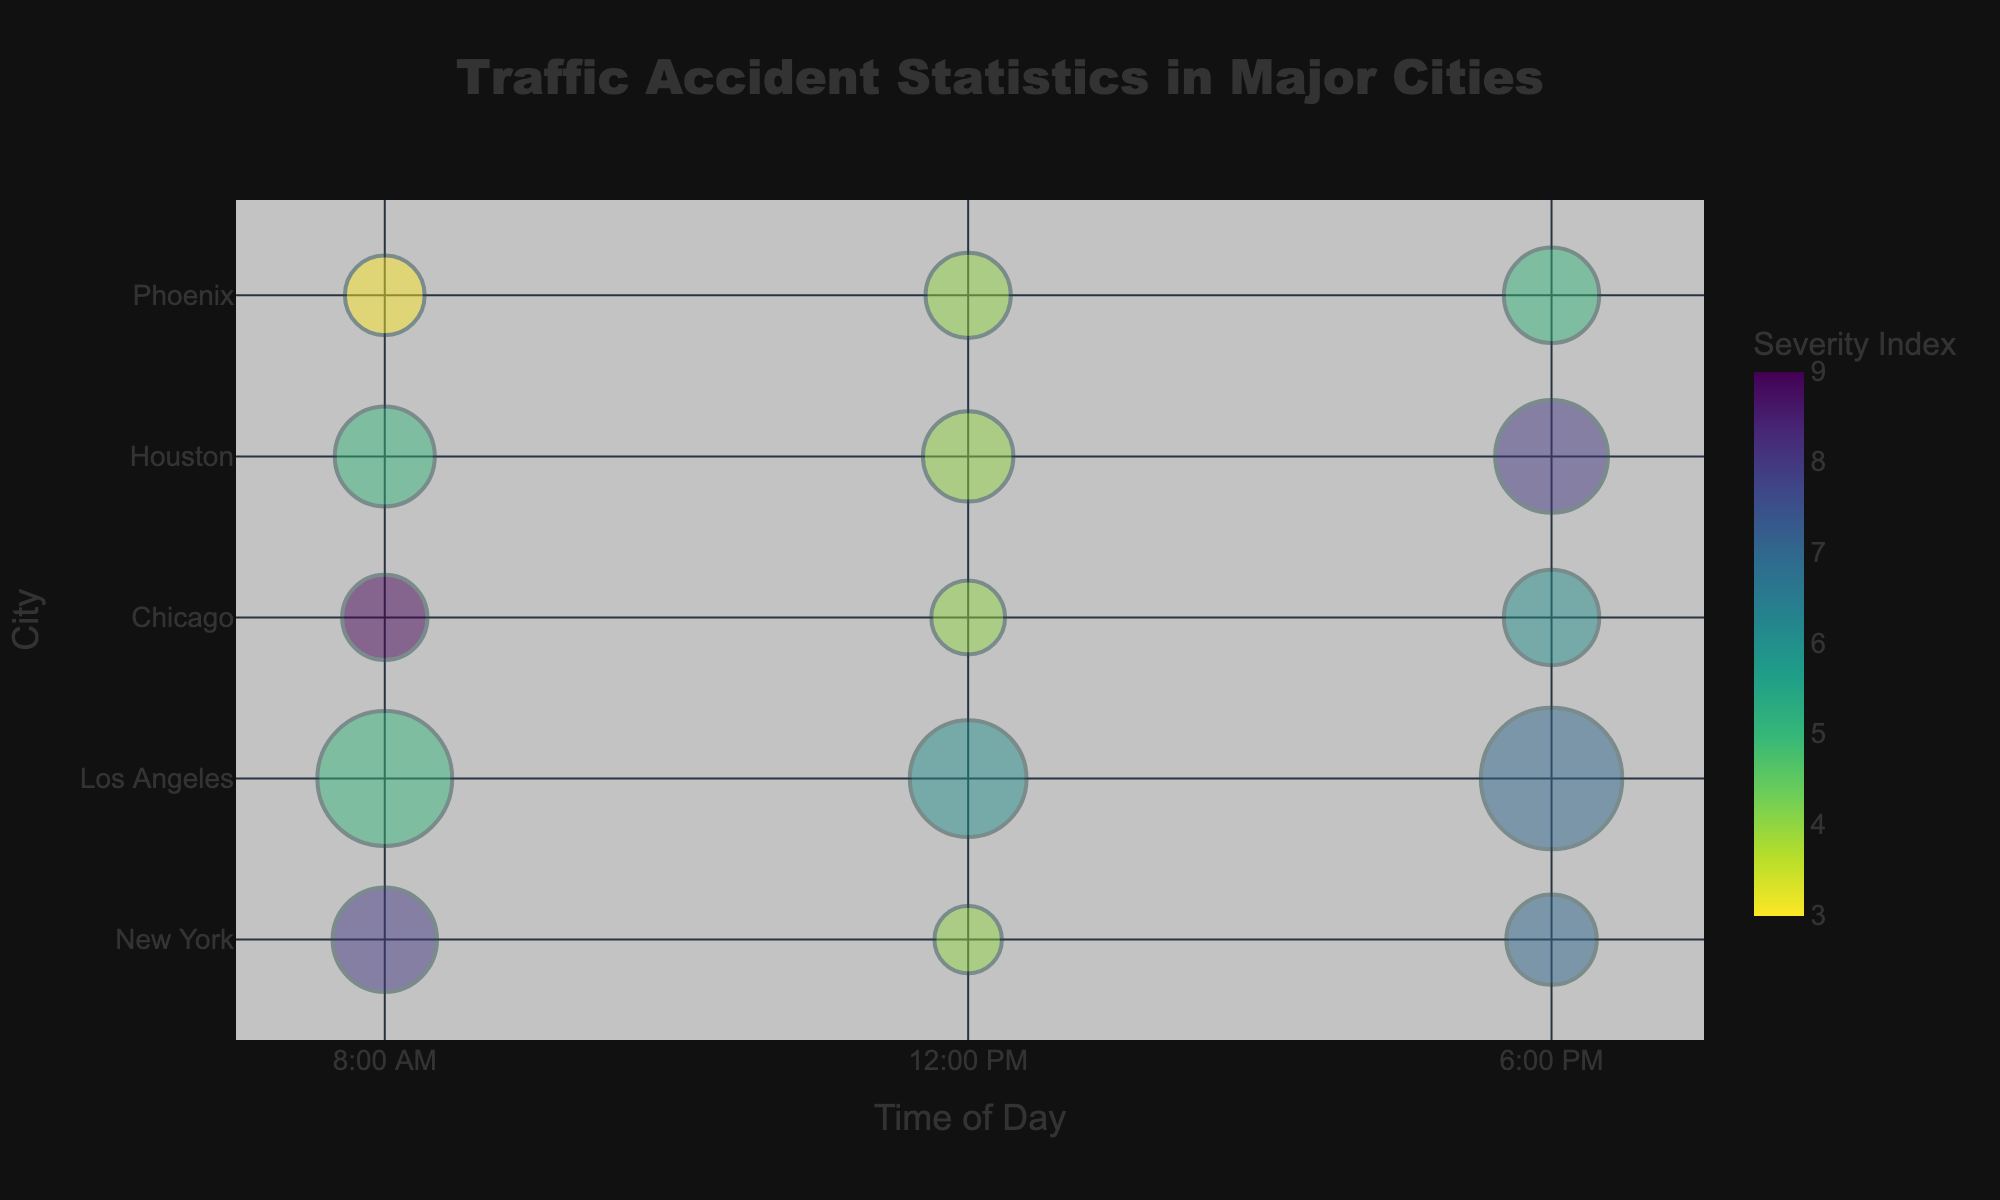What is the title of the bubble chart? The title is prominently displayed at the top center of the figure.
Answer: Traffic Accident Statistics in Major Cities How many major cities are represented in the bubble chart? The y-axis labels each major city included in the chart. By counting these labels, you can determine the number of cities.
Answer: 5 Which city had the highest number of traffic accidents at 6:00 PM? Identify the largest bubble at the 6:00 PM mark on the x-axis and check its y-axis positioning to find the corresponding city.
Answer: Los Angeles What time of day had the highest severity index in New York? Look for the bubble with the darkest color within the New York row to determine the corresponding time of day.
Answer: 8:00 AM Which weather condition is associated with traffic accidents in Houston at 6:00 PM? Hover over or check the data linked to the bubble at the 6:00 PM mark for Houston to find the weather condition listed.
Answer: Thunderstorm What is the combined number of traffic accidents for Los Angeles at 8:00 AM and 6:00 PM? Identify the bubble sizes for Los Angeles at 8:00 AM and 6:00 PM, and sum them up: 20 (8:00 AM) + 22 (6:00 PM).
Answer: 42 How many bubbles have the same size as the one representing Phoenix at 8:00 AM? Note the size of the bubble for Phoenix at 8:00 AM and count similar-sized bubbles across the chart.
Answer: 0 What time of day has the lowest severity index in Chicago? Look for the lightest-colored bubble within the Chicago row, indicating the lowest severity index, and note the time.
Answer: 12:00 PM Which city has the least number of accidents during clear weather at 12:00 PM? Compare the bubble sizes for each city at 12:00 PM with clear weather to find the smallest bubble.
Answer: New York How many bubbles are present on the chart in total? Count all the bubbles represented in both rows and columns throughout the figure.
Answer: 15 